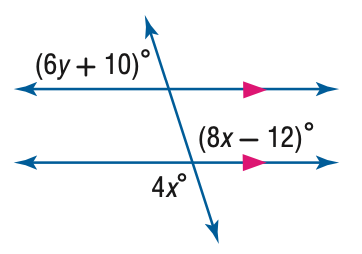Question: Find y in the figure.
Choices:
A. 12
B. 26.3
C. 28
D. 168
Answer with the letter. Answer: B 